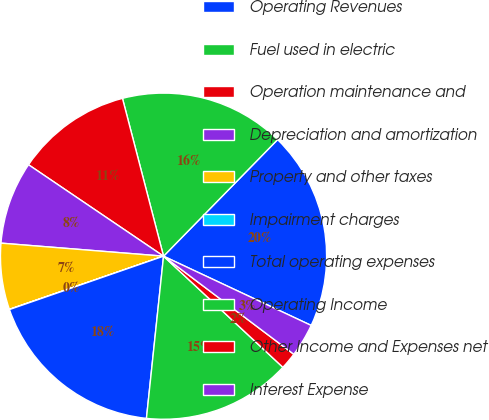Convert chart to OTSL. <chart><loc_0><loc_0><loc_500><loc_500><pie_chart><fcel>Operating Revenues<fcel>Fuel used in electric<fcel>Operation maintenance and<fcel>Depreciation and amortization<fcel>Property and other taxes<fcel>Impairment charges<fcel>Total operating expenses<fcel>Operating Income<fcel>Other Income and Expenses net<fcel>Interest Expense<nl><fcel>19.65%<fcel>16.38%<fcel>11.47%<fcel>8.2%<fcel>6.56%<fcel>0.02%<fcel>18.02%<fcel>14.74%<fcel>1.66%<fcel>3.29%<nl></chart> 